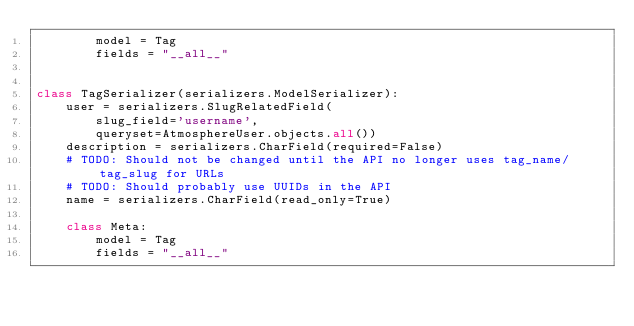Convert code to text. <code><loc_0><loc_0><loc_500><loc_500><_Python_>        model = Tag
        fields = "__all__"


class TagSerializer(serializers.ModelSerializer):
    user = serializers.SlugRelatedField(
        slug_field='username',
        queryset=AtmosphereUser.objects.all())
    description = serializers.CharField(required=False)
    # TODO: Should not be changed until the API no longer uses tag_name/tag_slug for URLs
    # TODO: Should probably use UUIDs in the API
    name = serializers.CharField(read_only=True)

    class Meta:
        model = Tag
        fields = "__all__"
</code> 